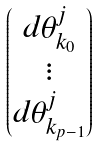Convert formula to latex. <formula><loc_0><loc_0><loc_500><loc_500>\begin{pmatrix} d \theta ^ { j } _ { k _ { 0 } } \\ \vdots \\ d \theta ^ { j } _ { k _ { p - 1 } } \end{pmatrix}</formula> 